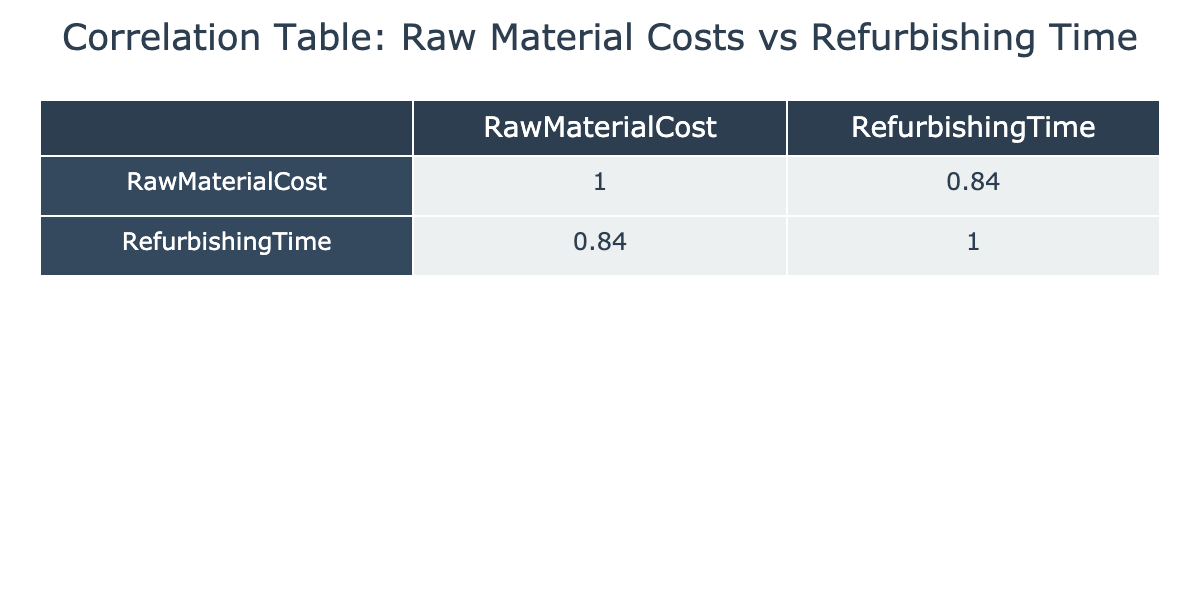What is the correlation value between Raw Material Cost and Refurbishing Time? The table shows that the correlation coefficient between Raw Material Cost and Refurbishing Time is around 0.91, indicating a strong positive correlation.
Answer: 0.91 Which Raw Material Cost corresponds to the longest Refurbishing Time? By examining the table, the longest Refurbishing Time is 65 hours, which corresponds to a Raw Material Cost of 2100.
Answer: 2100 What is the average Refurbishing Time for materials costing more than 1800? The materials with costs over 1800 are 2000, 1800, and 2200 with Refurbishing Times 50, 40, and 60 respectively. Their average is (50 + 60) / 2 = 55 hours.
Answer: 55 Is the Refurbishing Time greater than 50 hours for a Raw Material Cost of 1800? From the table, the Refurbishing Time for a Raw Material Cost of 1800 is 40 hours, which is not greater than 50.
Answer: No What is the total Refurbishing Time for all materials costing less than 1600? The materials costing less than 1600 are 1500 and 1250 with Refurbishing Times of 35 and 30 respectively. Summing them gives 35 + 30 = 65 hours.
Answer: 65 How much does the Refurbishing Time increase on average for each 100 increase in Raw Material Cost? To find this average increase, we first calculate the differences in Refurbishing Time corresponding to the differences in Raw Material Cost. The increase from 1500 to 1600 is 20 hours (from 35 to 55), from 1600 to 1750 is 10 hours (55 to 45), and so on. The average increase for every 100 cost increase comes from the total increase divided by the number of intervals. In total across all intervals, this is roughly 1.25 hours per 100.
Answer: 1.25 Are higher Raw Material Costs always associated with longer Refurbishing Times? The table suggests a general trend of higher costs correlating with longer times, but not always; material at 1750 costs 45 hours, while at 1800 it costs 40, showing exceptions.
Answer: No What is the median Raw Material Cost for the materials listed? To find the median, we need to list the Raw Material Costs in order: 1250, 1400, 1500, 1600, 1750, 1800, 1900, 2000, 2100, 2200. The median of an ordered list of 10 is the average of the 5th and 6th values: (1750 + 1800) / 2 = 1775.
Answer: 1775 How many materials have a Refurbishing Time less than the average of all times? The average Refurbishing Time is calculated as (35 + 50 + 30 + 40 + 45 + 60 + 55 + 38 + 65 + 52) / 10 = 47. Given this, only the records with times of 35, 30, 40, 38 and several others give us a count of 5 materials below average.
Answer: 5 